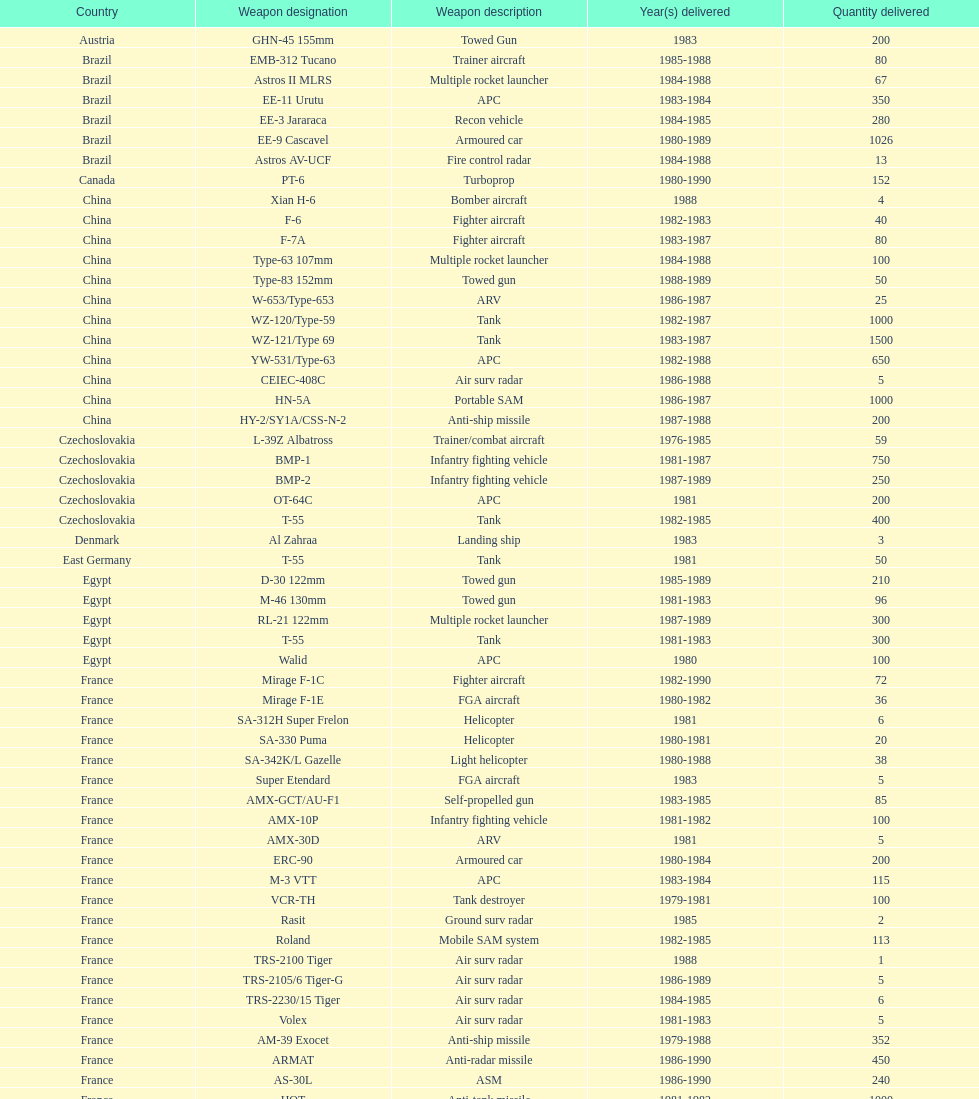What is the total number of tanks sold by china to iraq? 2500. 